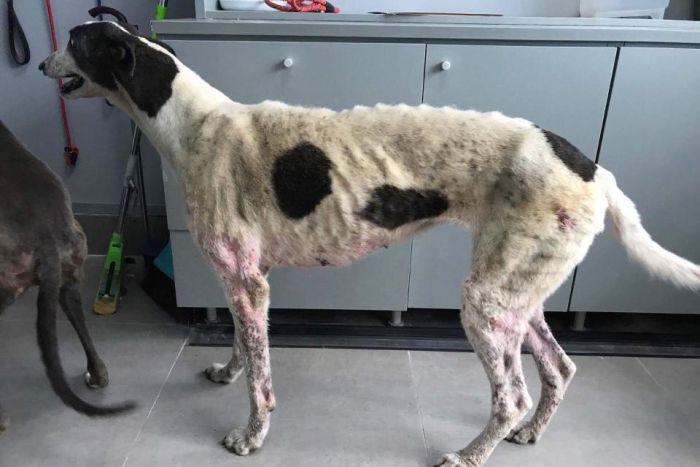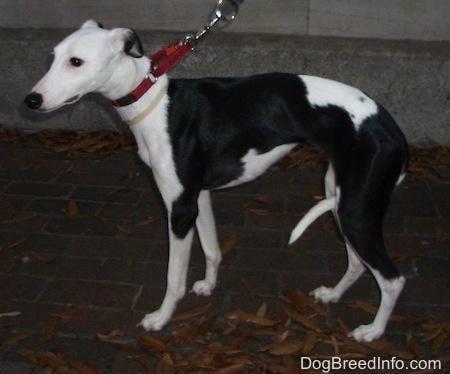The first image is the image on the left, the second image is the image on the right. Considering the images on both sides, is "The dog in the right image has a red collar around its neck." valid? Answer yes or no. Yes. The first image is the image on the left, the second image is the image on the right. For the images displayed, is the sentence "There are two dogs in total and one of them is wearing a collar." factually correct? Answer yes or no. Yes. 